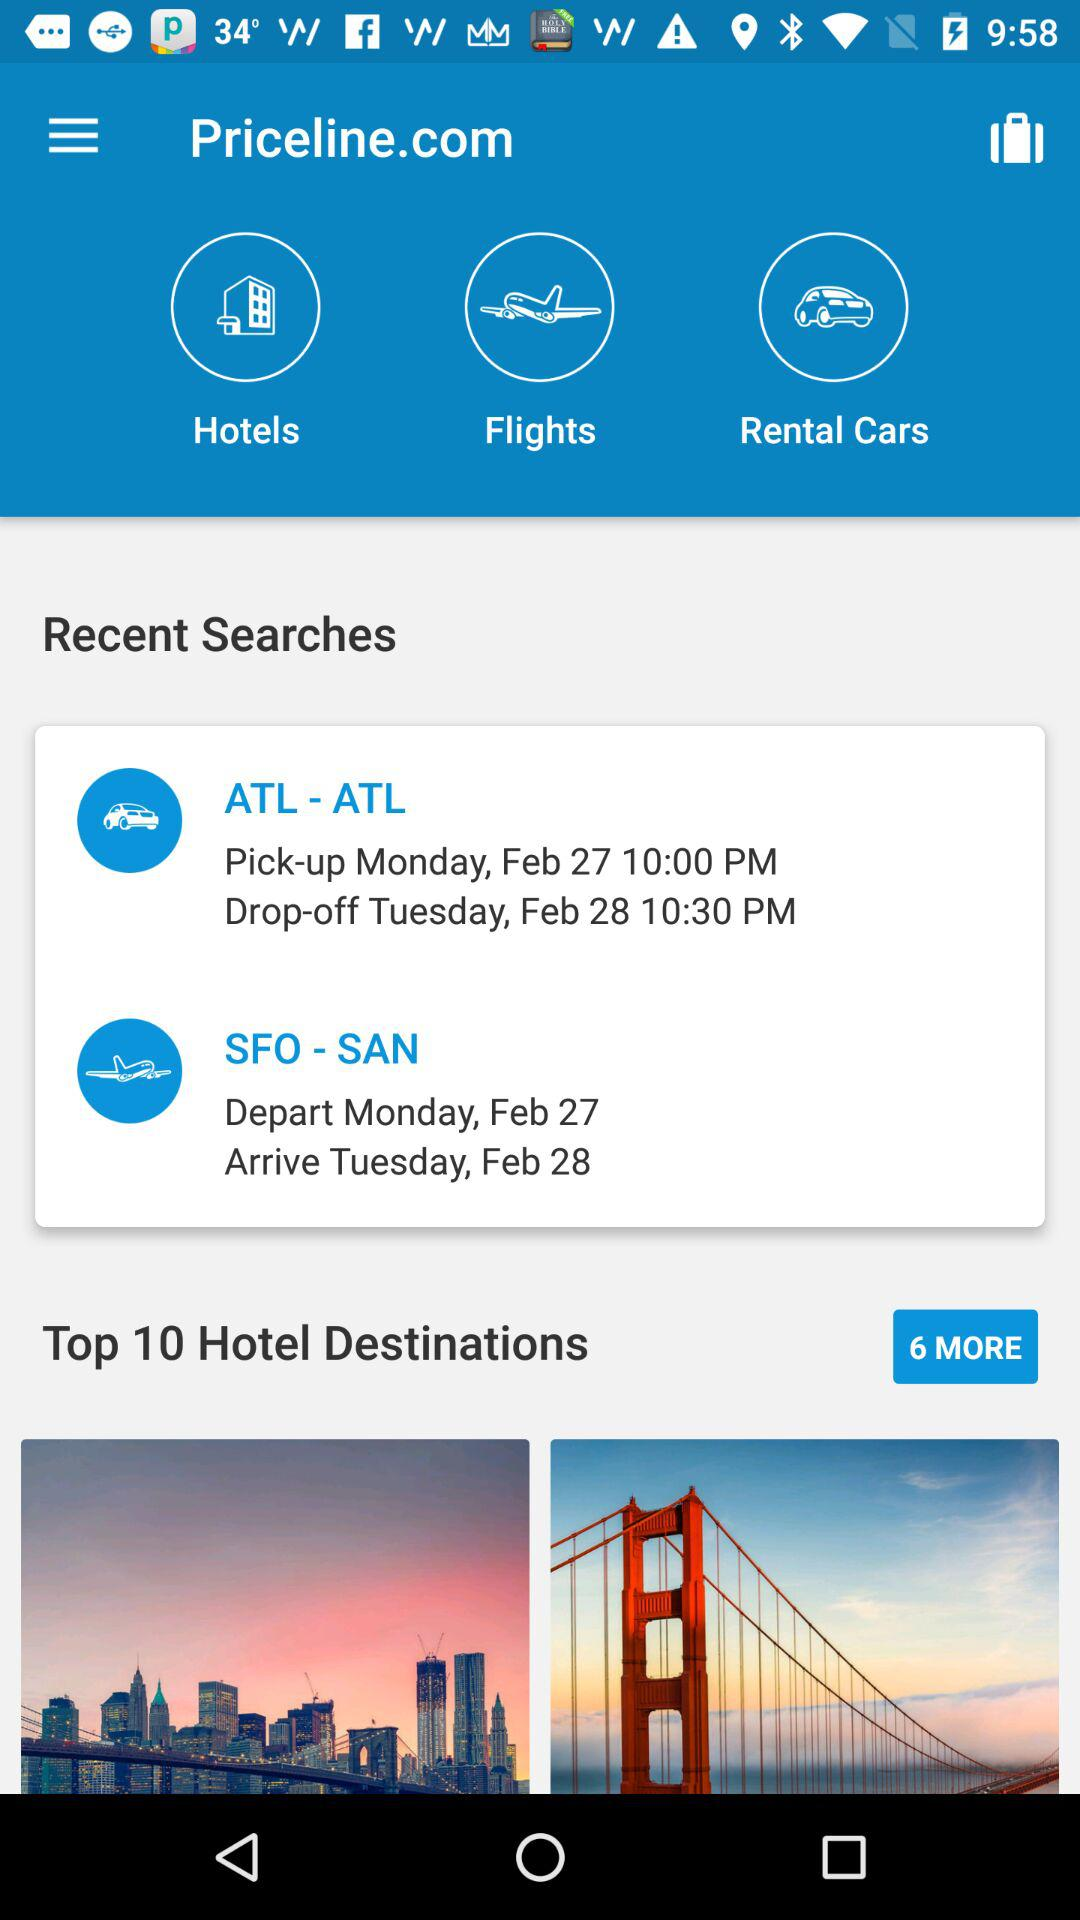What are the departure and arrival dates for SFO to SAN? The departure date is Monday, February 27 and the arrival date is Tuesday, February 28. 